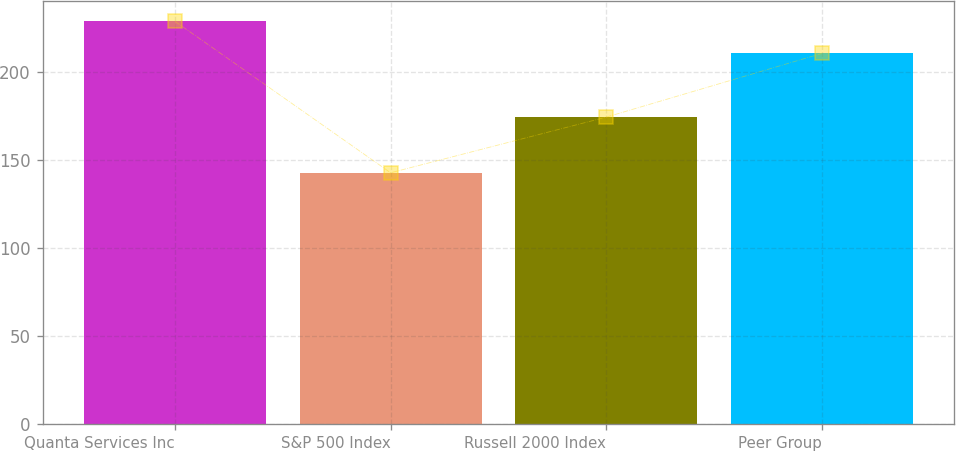Convert chart to OTSL. <chart><loc_0><loc_0><loc_500><loc_500><bar_chart><fcel>Quanta Services Inc<fcel>S&P 500 Index<fcel>Russell 2000 Index<fcel>Peer Group<nl><fcel>228.57<fcel>142.69<fcel>174.24<fcel>210.36<nl></chart> 